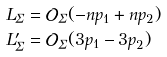<formula> <loc_0><loc_0><loc_500><loc_500>L _ { \Sigma } & = \mathcal { O } _ { \Sigma } ( - n p _ { 1 } + n p _ { 2 } ) \\ L _ { \Sigma } ^ { \prime } & = \mathcal { O } _ { \Sigma } ( 3 p _ { 1 } - 3 p _ { 2 } )</formula> 